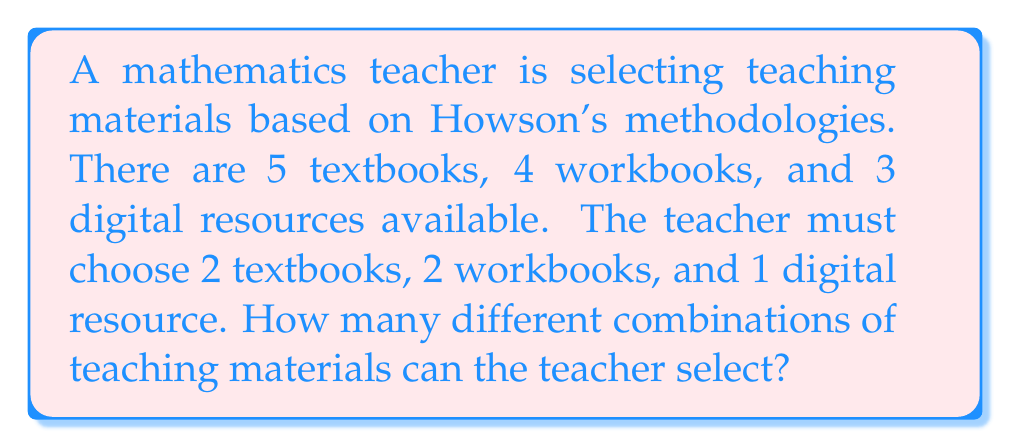What is the answer to this math problem? Let's approach this step-by-step using the multiplication principle and combinations:

1. Selecting textbooks:
   We need to choose 2 textbooks out of 5. This is a combination problem.
   Number of ways to select textbooks = $\binom{5}{2} = \frac{5!}{2!(5-2)!} = \frac{5 \cdot 4}{2 \cdot 1} = 10$

2. Selecting workbooks:
   We need to choose 2 workbooks out of 4. Again, this is a combination.
   Number of ways to select workbooks = $\binom{4}{2} = \frac{4!}{2!(4-2)!} = \frac{4 \cdot 3}{2 \cdot 1} = 6$

3. Selecting digital resources:
   We need to choose 1 digital resource out of 3. This is also a combination.
   Number of ways to select digital resources = $\binom{3}{1} = \frac{3!}{1!(3-1)!} = 3$

4. Applying the multiplication principle:
   The total number of possible combinations is the product of the individual selections.
   Total combinations = $10 \cdot 6 \cdot 3 = 180$

Therefore, the teacher can select teaching materials in 180 different ways.
Answer: 180 